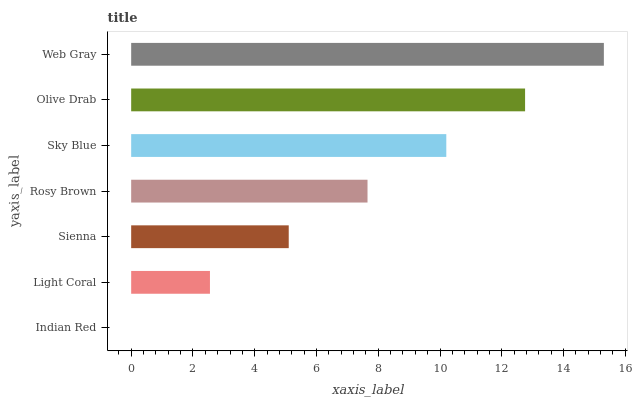Is Indian Red the minimum?
Answer yes or no. Yes. Is Web Gray the maximum?
Answer yes or no. Yes. Is Light Coral the minimum?
Answer yes or no. No. Is Light Coral the maximum?
Answer yes or no. No. Is Light Coral greater than Indian Red?
Answer yes or no. Yes. Is Indian Red less than Light Coral?
Answer yes or no. Yes. Is Indian Red greater than Light Coral?
Answer yes or no. No. Is Light Coral less than Indian Red?
Answer yes or no. No. Is Rosy Brown the high median?
Answer yes or no. Yes. Is Rosy Brown the low median?
Answer yes or no. Yes. Is Light Coral the high median?
Answer yes or no. No. Is Light Coral the low median?
Answer yes or no. No. 